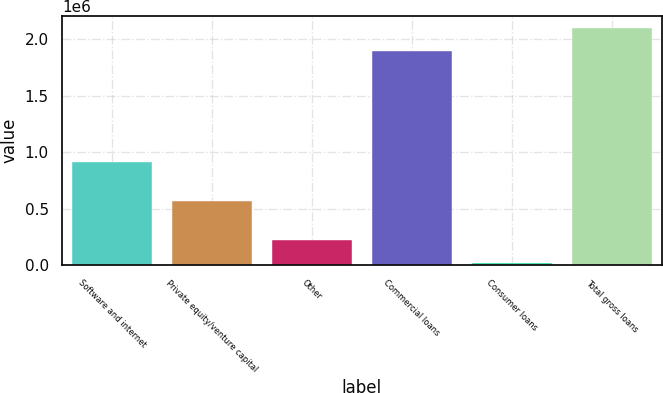<chart> <loc_0><loc_0><loc_500><loc_500><bar_chart><fcel>Software and internet<fcel>Private equity/venture capital<fcel>Other<fcel>Commercial loans<fcel>Consumer loans<fcel>Total gross loans<nl><fcel>917546<fcel>568743<fcel>220477<fcel>1.90125e+06<fcel>20000<fcel>2.10173e+06<nl></chart> 